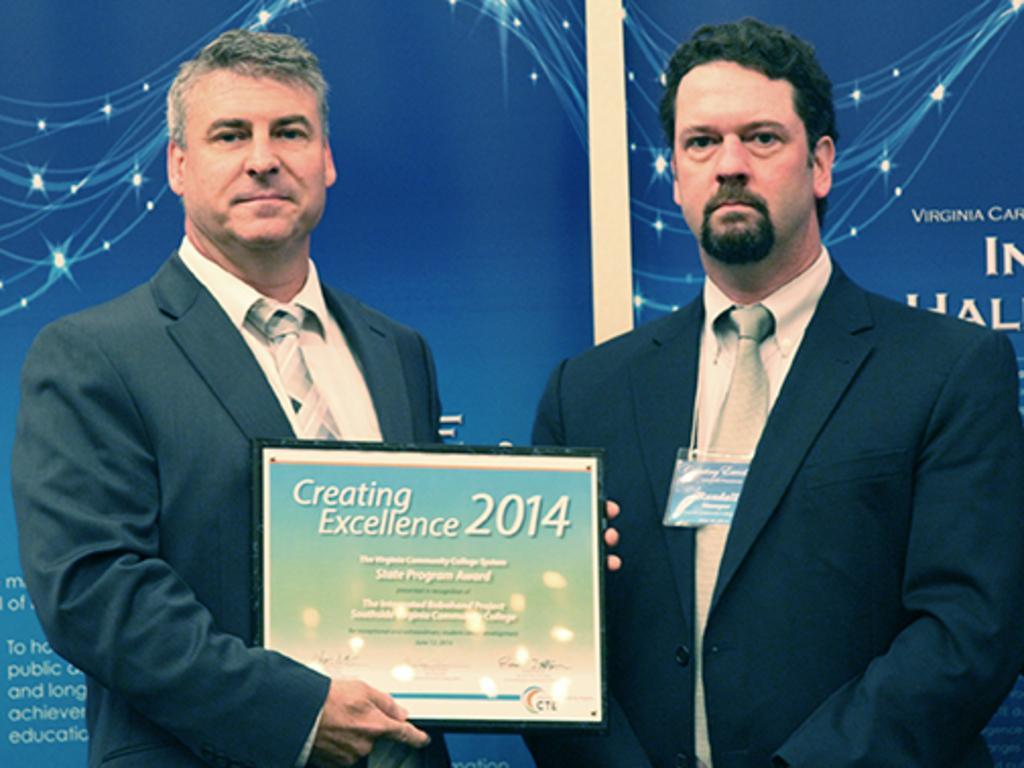Can you describe this image briefly? In this image we can see two persons standing and posing for a photo and one among them is holding an object and there is some text on it. In the background, we can see the banner with some text. 